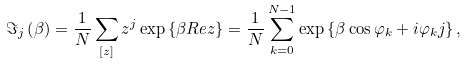<formula> <loc_0><loc_0><loc_500><loc_500>\Im _ { j } \left ( \beta \right ) = \frac { 1 } { N } \sum _ { \left [ z \right ] } z ^ { j } \exp \left \{ \beta R e z \right \} = \frac { 1 } { N } \sum _ { k = 0 } ^ { N - 1 } \exp \left \{ \beta \cos \varphi _ { k } + i \varphi _ { k } j \right \} ,</formula> 